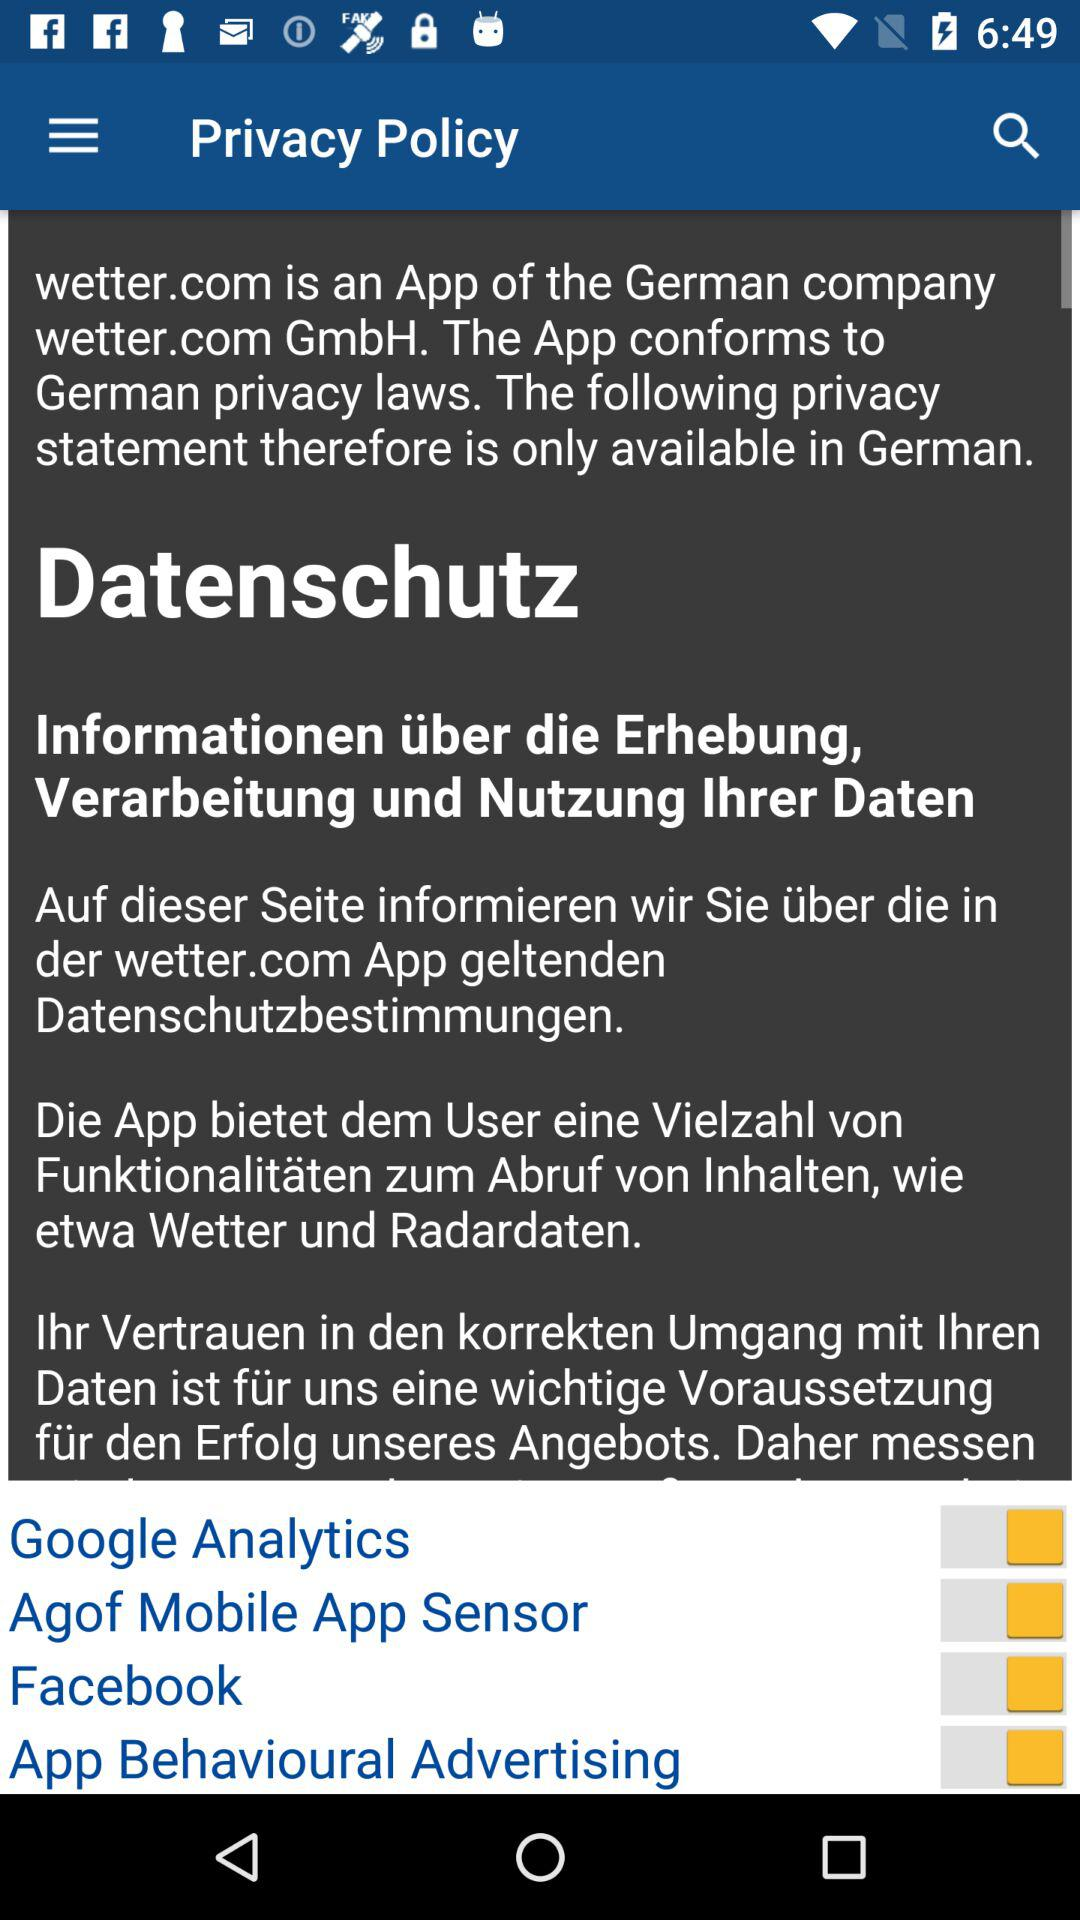What is the status of the Agof Mobile App Sensor? The setting is on. 